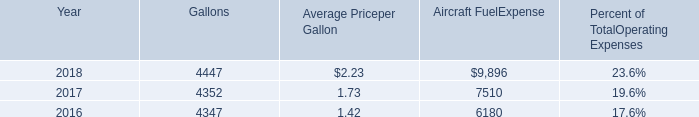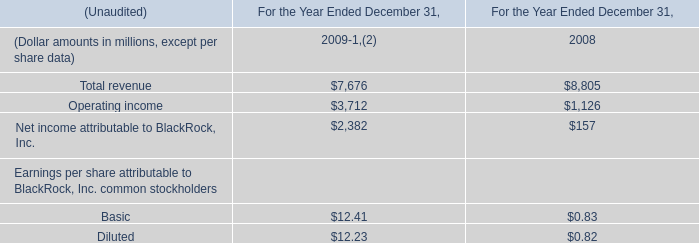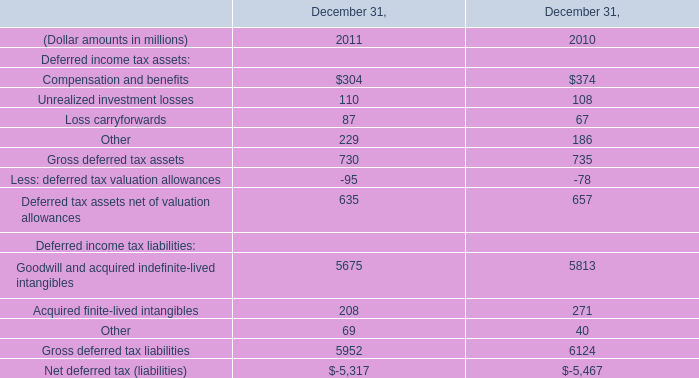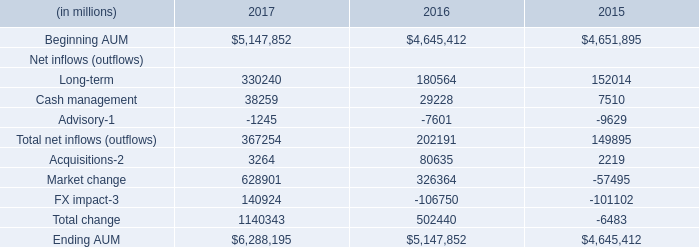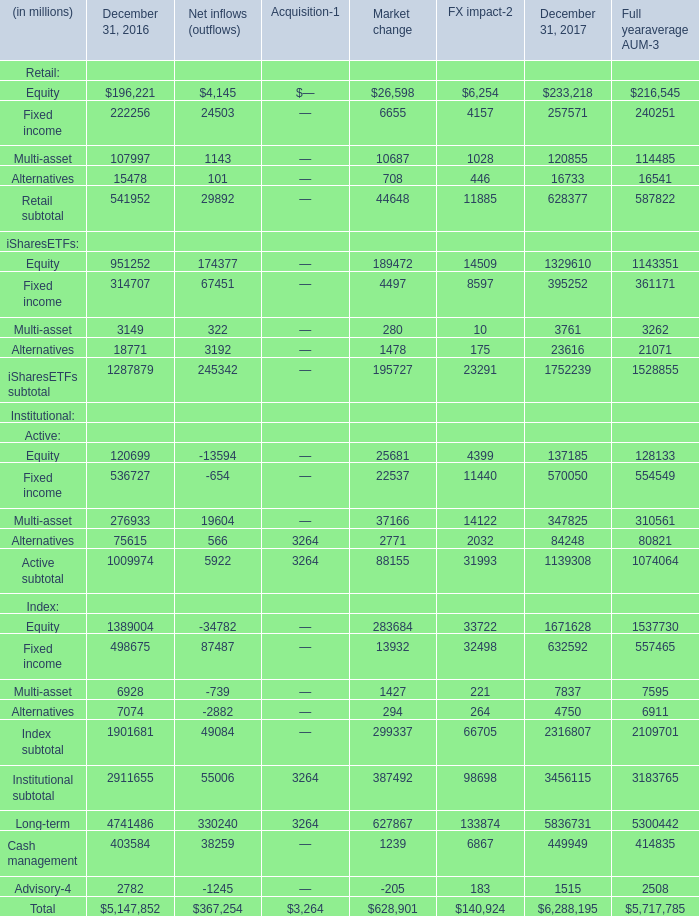If Retail subtotal develops with the same increasing rate in 2017, what will it reach in 2018? (in dollars in millions) 
Computations: (628377 * (1 + ((628377 - 541952) / 541952)))
Answer: 728584.18112. 